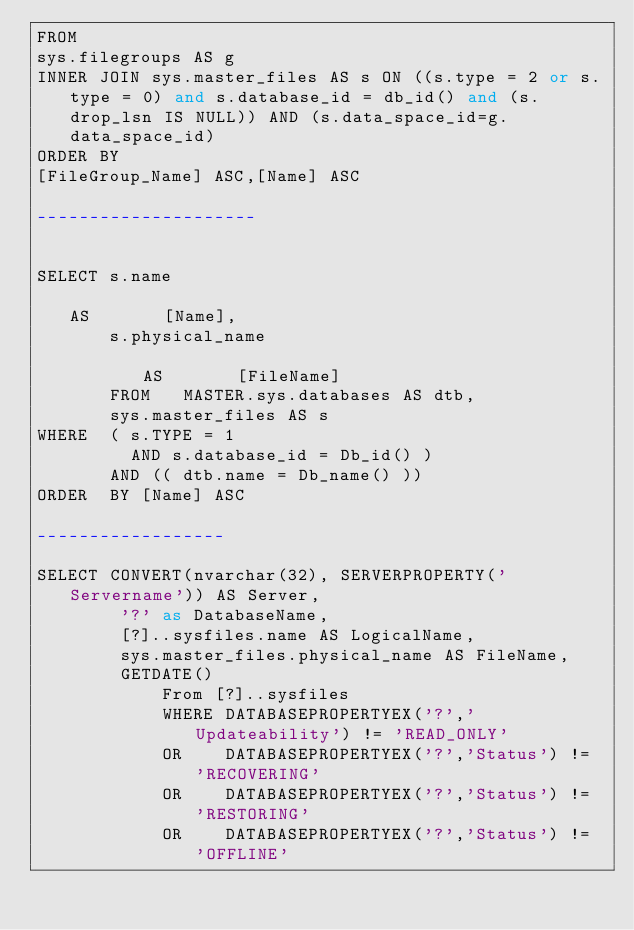Convert code to text. <code><loc_0><loc_0><loc_500><loc_500><_SQL_>FROM
sys.filegroups AS g
INNER JOIN sys.master_files AS s ON ((s.type = 2 or s.type = 0) and s.database_id = db_id() and (s.drop_lsn IS NULL)) AND (s.data_space_id=g.data_space_id)
ORDER BY
[FileGroup_Name] ASC,[Name] ASC

---------------------


SELECT s.name                                                               AS       [Name],
       s.physical_name                                                      AS       [FileName]
       FROM   MASTER.sys.databases AS dtb,
       sys.master_files AS s
WHERE  ( s.TYPE = 1
         AND s.database_id = Db_id() )
       AND (( dtb.name = Db_name() ))
ORDER  BY [Name] ASC

------------------

SELECT CONVERT(nvarchar(32), SERVERPROPERTY('Servername')) AS Server,
		'?' as DatabaseName,
		[?]..sysfiles.name AS LogicalName, 
		sys.master_files.physical_name AS FileName,
		GETDATE()
			From [?]..sysfiles
			WHERE DATABASEPROPERTYEX('?','Updateability') != 'READ_ONLY'
			OR	  DATABASEPROPERTYEX('?','Status') != 'RECOVERING'
			OR	  DATABASEPROPERTYEX('?','Status') != 'RESTORING'
			OR	  DATABASEPROPERTYEX('?','Status') != 'OFFLINE'</code> 